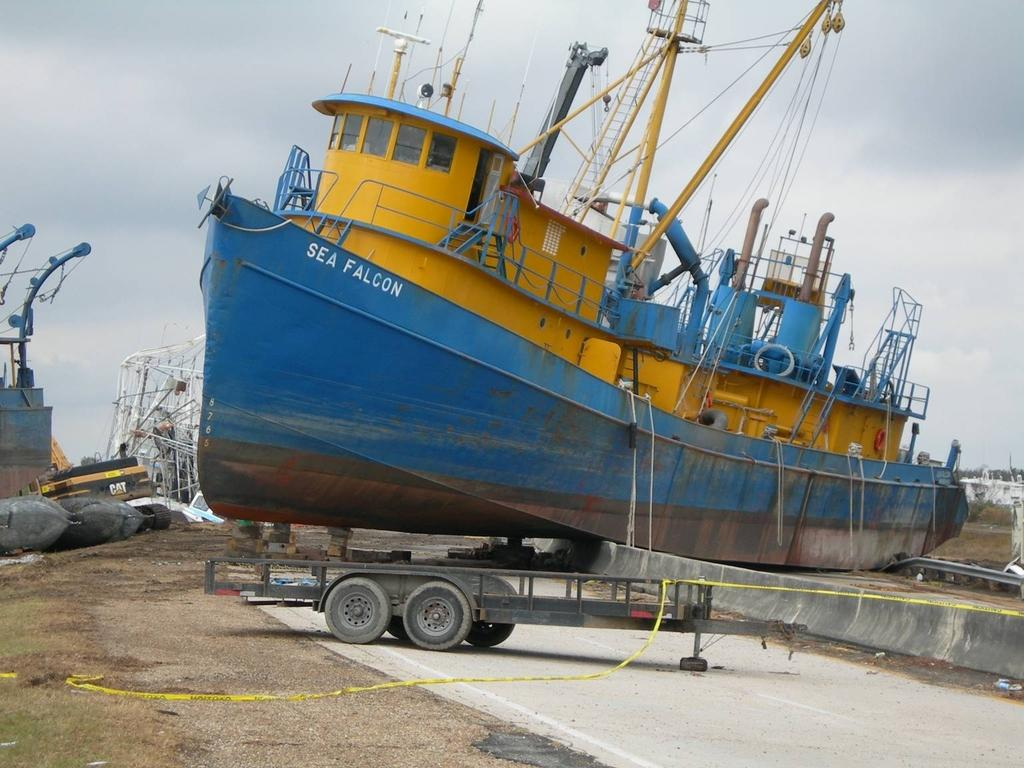<image>
Share a concise interpretation of the image provided. Blue and yellow ship which says SEA FALCON on it. 